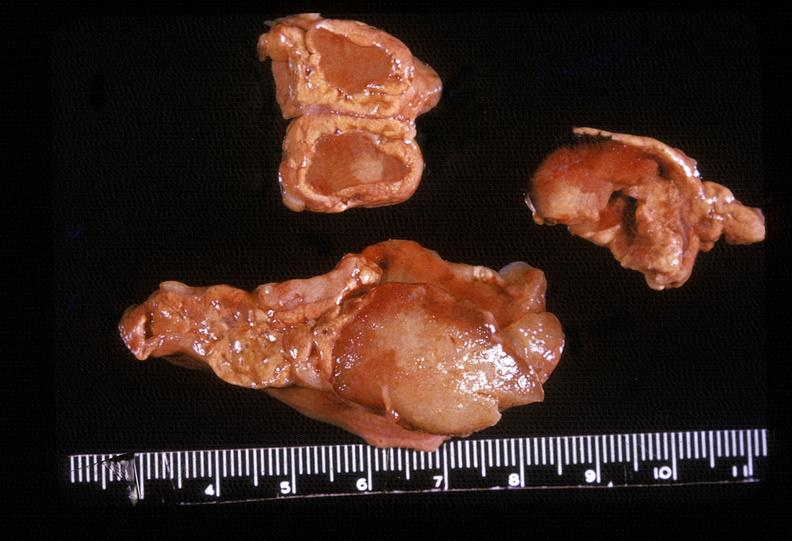where does this belong to?
Answer the question using a single word or phrase. Endocrine system 